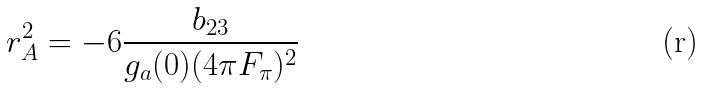<formula> <loc_0><loc_0><loc_500><loc_500>r _ { A } ^ { 2 } = - 6 \frac { b _ { 2 3 } } { g _ { a } ( 0 ) ( 4 { \pi } F _ { \pi } ) ^ { 2 } }</formula> 